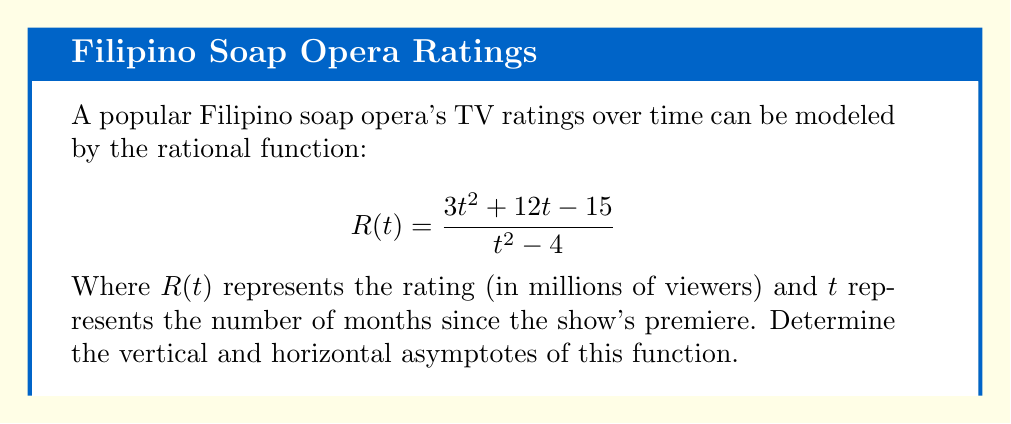Solve this math problem. To find the asymptotes of this rational function, we'll follow these steps:

1. Vertical asymptotes:
   Vertical asymptotes occur when the denominator equals zero.
   Solve $t^2 - 4 = 0$
   $(t+2)(t-2) = 0$
   $t = -2$ or $t = 2$

2. Horizontal asymptote:
   To find the horizontal asymptote, compare the degrees of the numerator and denominator.
   Degree of numerator = 2
   Degree of denominator = 2
   Since they are equal, the horizontal asymptote is the ratio of the leading coefficients.
   
   Horizontal asymptote = $\frac{3}{1} = 3$

3. There are no slant asymptotes because the degrees of the numerator and denominator are equal.

Therefore, the vertical asymptotes are at $t = -2$ and $t = 2$, and the horizontal asymptote is at $R = 3$.
Answer: Vertical asymptotes: $t = -2, t = 2$; Horizontal asymptote: $R = 3$ 